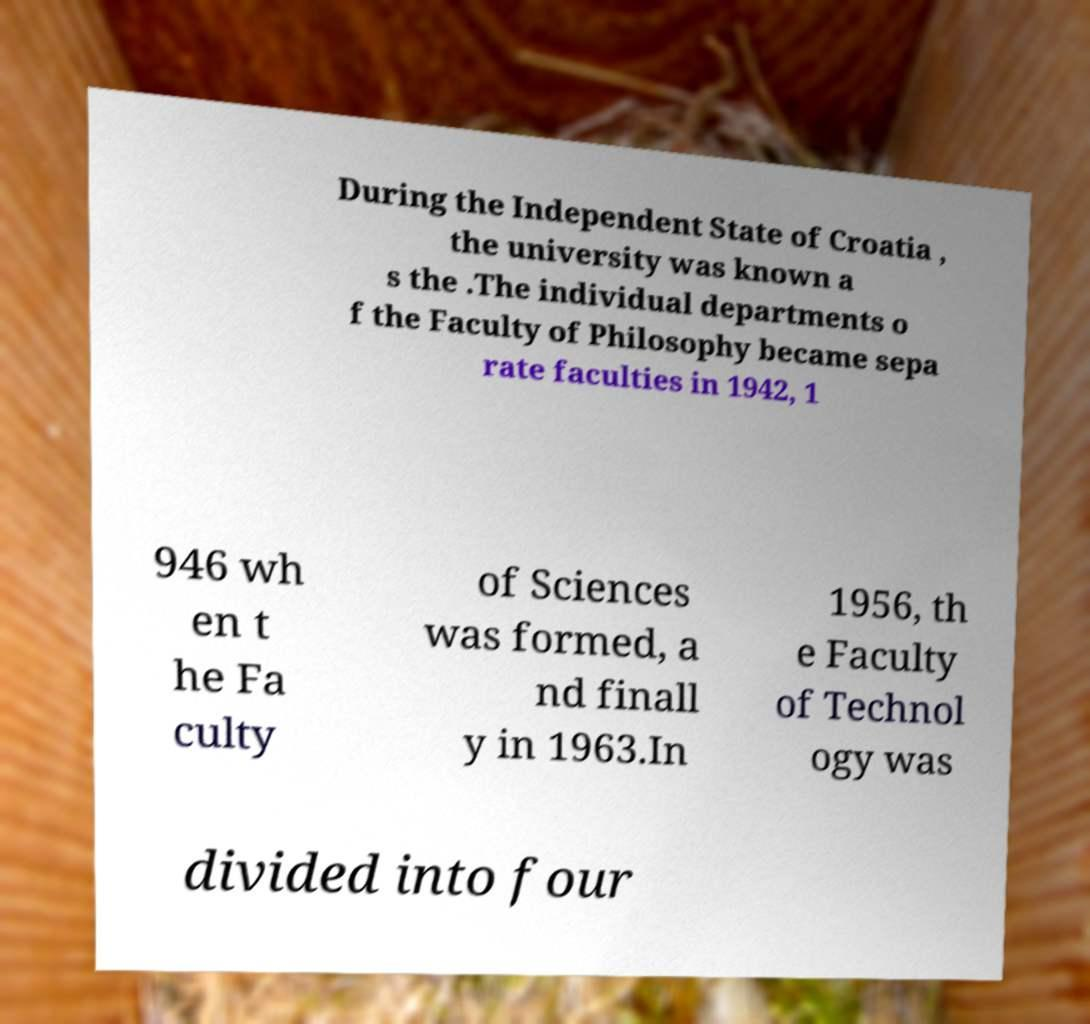For documentation purposes, I need the text within this image transcribed. Could you provide that? During the Independent State of Croatia , the university was known a s the .The individual departments o f the Faculty of Philosophy became sepa rate faculties in 1942, 1 946 wh en t he Fa culty of Sciences was formed, a nd finall y in 1963.In 1956, th e Faculty of Technol ogy was divided into four 